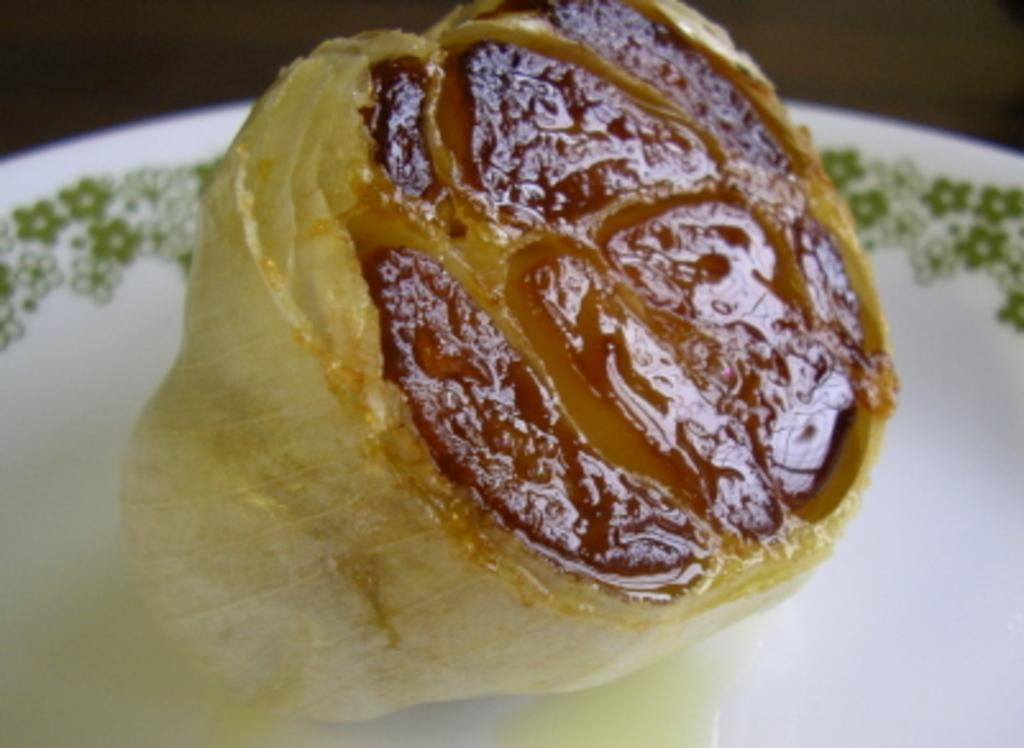What is present in the image related to food? There is food in the image. How is the food arranged or presented in the image? The food is in a white plate. What type of linen can be seen draped over the food in the image? There is no linen draped over the food in the image. How many feet are visible in the image? There are no feet visible in the image. 